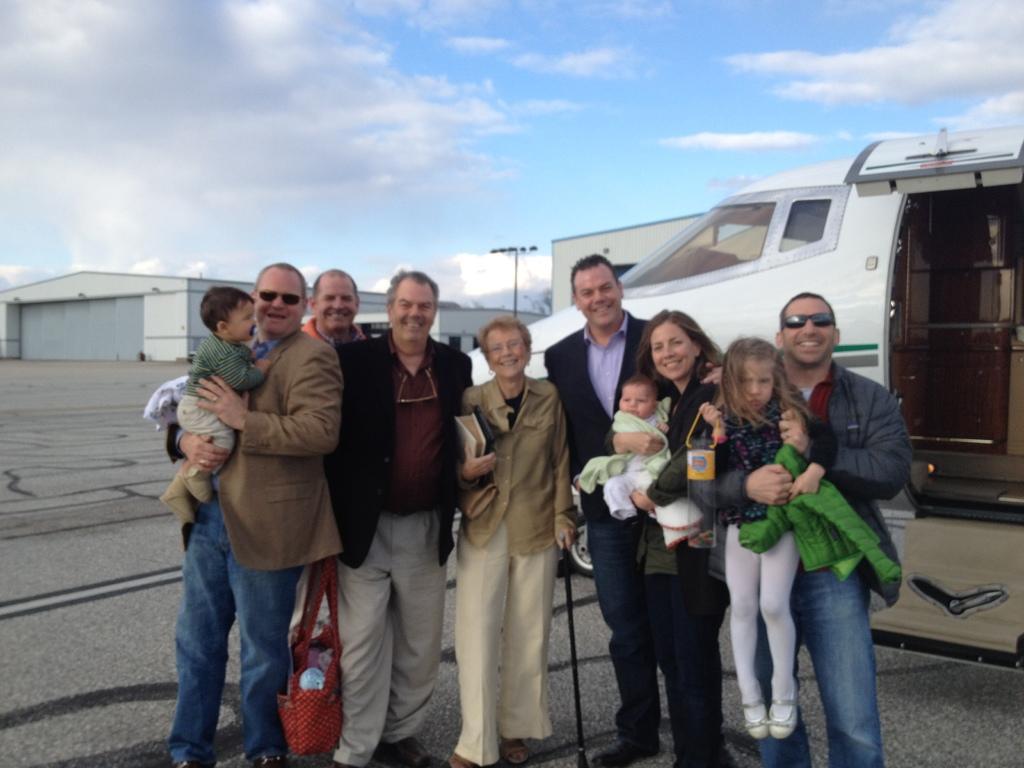Could you give a brief overview of what you see in this image? In this image there are group of people, and some of them are holding babies and some of them are holding bags and jackets. In the background there is some vehicle, and it looks like an airplane and also we could see some buildings, pole, lights. At the bottom there is walkway, and at the top there is sky. 